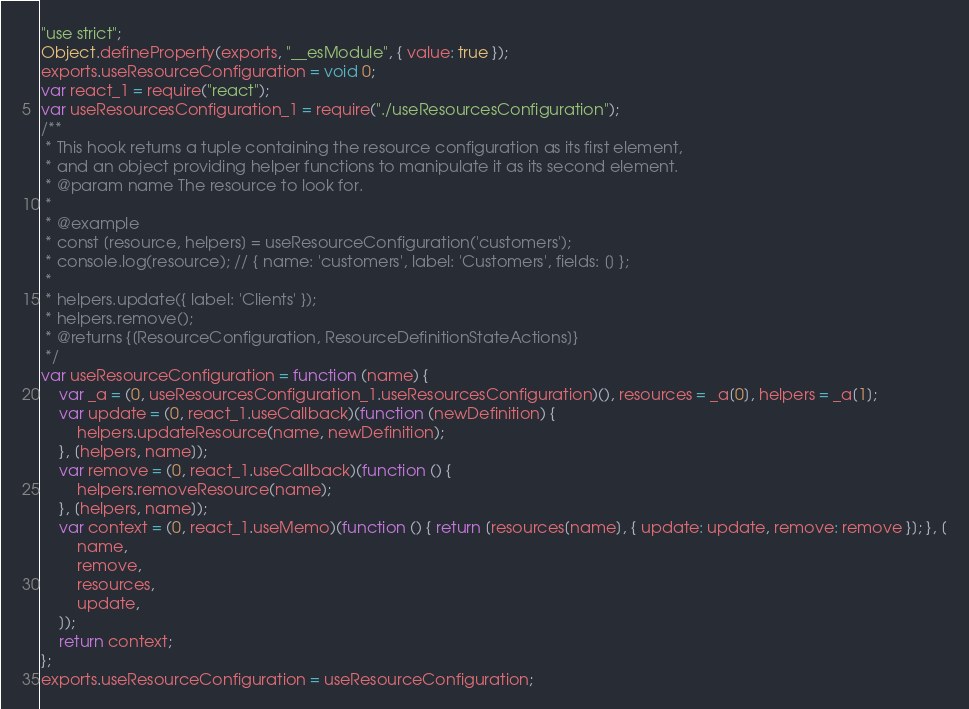<code> <loc_0><loc_0><loc_500><loc_500><_JavaScript_>"use strict";
Object.defineProperty(exports, "__esModule", { value: true });
exports.useResourceConfiguration = void 0;
var react_1 = require("react");
var useResourcesConfiguration_1 = require("./useResourcesConfiguration");
/**
 * This hook returns a tuple containing the resource configuration as its first element,
 * and an object providing helper functions to manipulate it as its second element.
 * @param name The resource to look for.
 *
 * @example
 * const [resource, helpers] = useResourceConfiguration('customers');
 * console.log(resource); // { name: 'customers', label: 'Customers', fields: [] };
 *
 * helpers.update({ label: 'Clients' });
 * helpers.remove();
 * @returns {[ResourceConfiguration, ResourceDefinitionStateActions]}
 */
var useResourceConfiguration = function (name) {
    var _a = (0, useResourcesConfiguration_1.useResourcesConfiguration)(), resources = _a[0], helpers = _a[1];
    var update = (0, react_1.useCallback)(function (newDefinition) {
        helpers.updateResource(name, newDefinition);
    }, [helpers, name]);
    var remove = (0, react_1.useCallback)(function () {
        helpers.removeResource(name);
    }, [helpers, name]);
    var context = (0, react_1.useMemo)(function () { return [resources[name], { update: update, remove: remove }]; }, [
        name,
        remove,
        resources,
        update,
    ]);
    return context;
};
exports.useResourceConfiguration = useResourceConfiguration;
</code> 